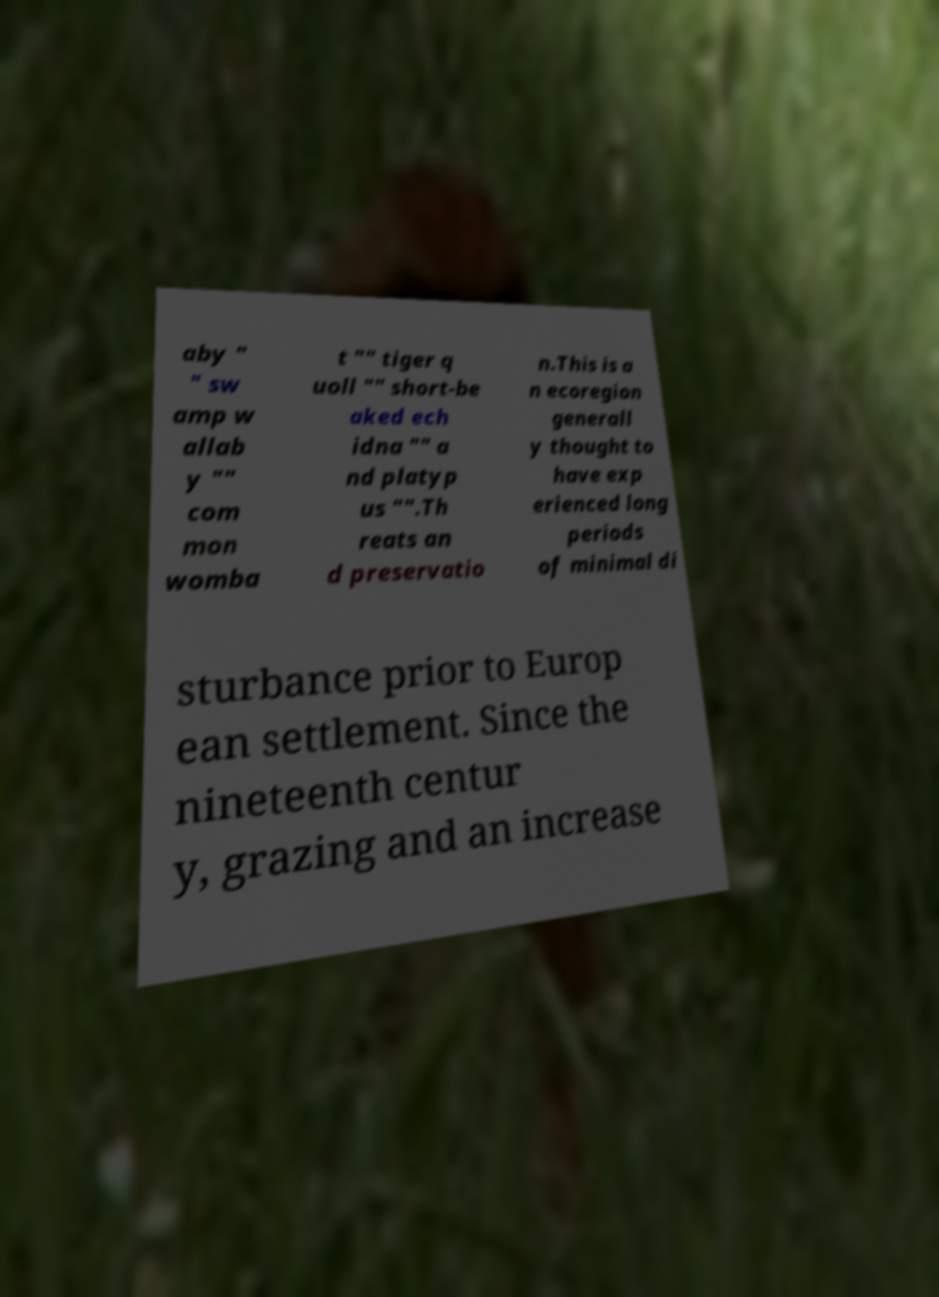Can you accurately transcribe the text from the provided image for me? aby " " sw amp w allab y "" com mon womba t "" tiger q uoll "" short-be aked ech idna "" a nd platyp us "".Th reats an d preservatio n.This is a n ecoregion generall y thought to have exp erienced long periods of minimal di sturbance prior to Europ ean settlement. Since the nineteenth centur y, grazing and an increase 